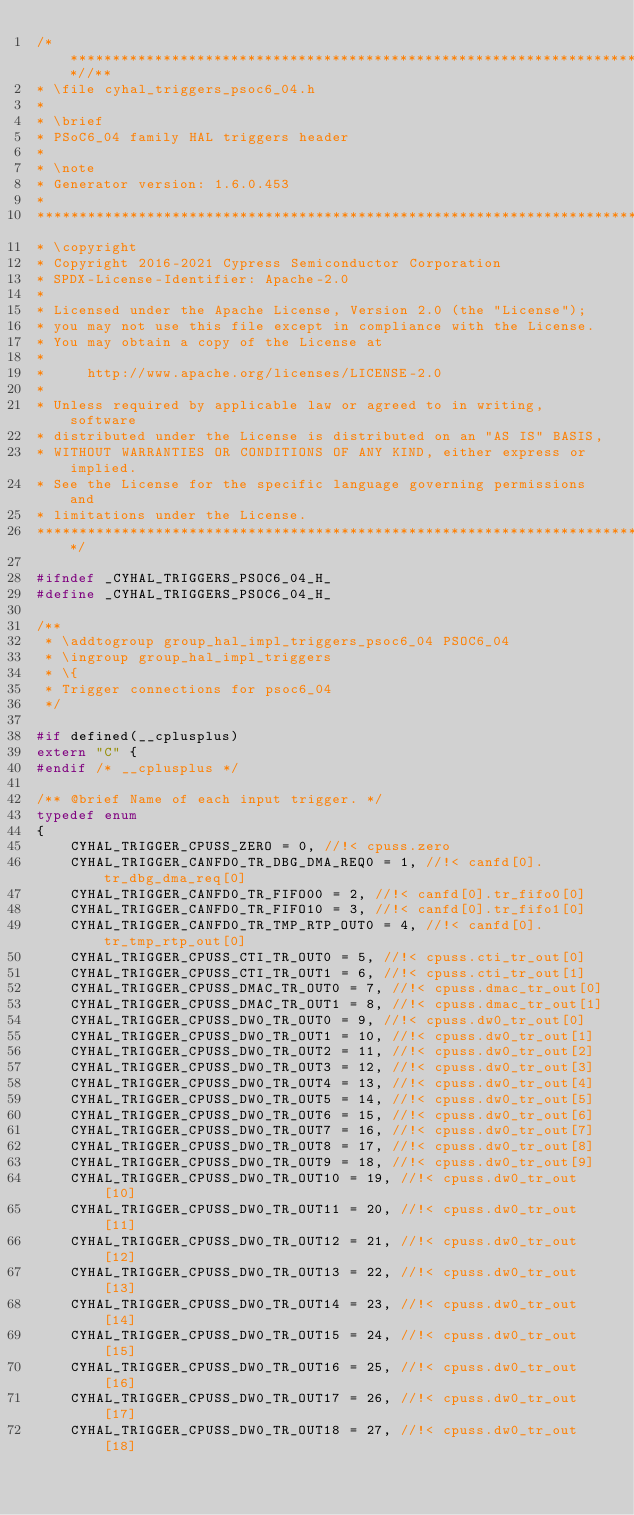<code> <loc_0><loc_0><loc_500><loc_500><_C_>/***************************************************************************//**
* \file cyhal_triggers_psoc6_04.h
*
* \brief
* PSoC6_04 family HAL triggers header
*
* \note
* Generator version: 1.6.0.453
*
********************************************************************************
* \copyright
* Copyright 2016-2021 Cypress Semiconductor Corporation
* SPDX-License-Identifier: Apache-2.0
*
* Licensed under the Apache License, Version 2.0 (the "License");
* you may not use this file except in compliance with the License.
* You may obtain a copy of the License at
*
*     http://www.apache.org/licenses/LICENSE-2.0
*
* Unless required by applicable law or agreed to in writing, software
* distributed under the License is distributed on an "AS IS" BASIS,
* WITHOUT WARRANTIES OR CONDITIONS OF ANY KIND, either express or implied.
* See the License for the specific language governing permissions and
* limitations under the License.
*******************************************************************************/

#ifndef _CYHAL_TRIGGERS_PSOC6_04_H_
#define _CYHAL_TRIGGERS_PSOC6_04_H_

/**
 * \addtogroup group_hal_impl_triggers_psoc6_04 PSOC6_04
 * \ingroup group_hal_impl_triggers
 * \{
 * Trigger connections for psoc6_04
 */

#if defined(__cplusplus)
extern "C" {
#endif /* __cplusplus */

/** @brief Name of each input trigger. */
typedef enum
{
    CYHAL_TRIGGER_CPUSS_ZERO = 0, //!< cpuss.zero
    CYHAL_TRIGGER_CANFD0_TR_DBG_DMA_REQ0 = 1, //!< canfd[0].tr_dbg_dma_req[0]
    CYHAL_TRIGGER_CANFD0_TR_FIFO00 = 2, //!< canfd[0].tr_fifo0[0]
    CYHAL_TRIGGER_CANFD0_TR_FIFO10 = 3, //!< canfd[0].tr_fifo1[0]
    CYHAL_TRIGGER_CANFD0_TR_TMP_RTP_OUT0 = 4, //!< canfd[0].tr_tmp_rtp_out[0]
    CYHAL_TRIGGER_CPUSS_CTI_TR_OUT0 = 5, //!< cpuss.cti_tr_out[0]
    CYHAL_TRIGGER_CPUSS_CTI_TR_OUT1 = 6, //!< cpuss.cti_tr_out[1]
    CYHAL_TRIGGER_CPUSS_DMAC_TR_OUT0 = 7, //!< cpuss.dmac_tr_out[0]
    CYHAL_TRIGGER_CPUSS_DMAC_TR_OUT1 = 8, //!< cpuss.dmac_tr_out[1]
    CYHAL_TRIGGER_CPUSS_DW0_TR_OUT0 = 9, //!< cpuss.dw0_tr_out[0]
    CYHAL_TRIGGER_CPUSS_DW0_TR_OUT1 = 10, //!< cpuss.dw0_tr_out[1]
    CYHAL_TRIGGER_CPUSS_DW0_TR_OUT2 = 11, //!< cpuss.dw0_tr_out[2]
    CYHAL_TRIGGER_CPUSS_DW0_TR_OUT3 = 12, //!< cpuss.dw0_tr_out[3]
    CYHAL_TRIGGER_CPUSS_DW0_TR_OUT4 = 13, //!< cpuss.dw0_tr_out[4]
    CYHAL_TRIGGER_CPUSS_DW0_TR_OUT5 = 14, //!< cpuss.dw0_tr_out[5]
    CYHAL_TRIGGER_CPUSS_DW0_TR_OUT6 = 15, //!< cpuss.dw0_tr_out[6]
    CYHAL_TRIGGER_CPUSS_DW0_TR_OUT7 = 16, //!< cpuss.dw0_tr_out[7]
    CYHAL_TRIGGER_CPUSS_DW0_TR_OUT8 = 17, //!< cpuss.dw0_tr_out[8]
    CYHAL_TRIGGER_CPUSS_DW0_TR_OUT9 = 18, //!< cpuss.dw0_tr_out[9]
    CYHAL_TRIGGER_CPUSS_DW0_TR_OUT10 = 19, //!< cpuss.dw0_tr_out[10]
    CYHAL_TRIGGER_CPUSS_DW0_TR_OUT11 = 20, //!< cpuss.dw0_tr_out[11]
    CYHAL_TRIGGER_CPUSS_DW0_TR_OUT12 = 21, //!< cpuss.dw0_tr_out[12]
    CYHAL_TRIGGER_CPUSS_DW0_TR_OUT13 = 22, //!< cpuss.dw0_tr_out[13]
    CYHAL_TRIGGER_CPUSS_DW0_TR_OUT14 = 23, //!< cpuss.dw0_tr_out[14]
    CYHAL_TRIGGER_CPUSS_DW0_TR_OUT15 = 24, //!< cpuss.dw0_tr_out[15]
    CYHAL_TRIGGER_CPUSS_DW0_TR_OUT16 = 25, //!< cpuss.dw0_tr_out[16]
    CYHAL_TRIGGER_CPUSS_DW0_TR_OUT17 = 26, //!< cpuss.dw0_tr_out[17]
    CYHAL_TRIGGER_CPUSS_DW0_TR_OUT18 = 27, //!< cpuss.dw0_tr_out[18]</code> 